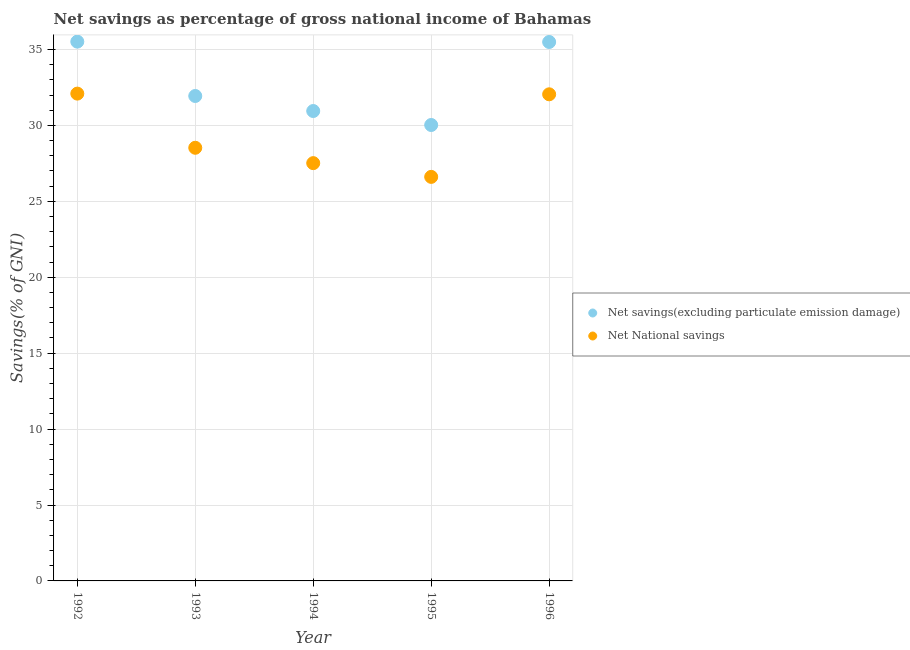How many different coloured dotlines are there?
Your response must be concise. 2. Is the number of dotlines equal to the number of legend labels?
Provide a succinct answer. Yes. What is the net national savings in 1996?
Offer a terse response. 32.05. Across all years, what is the maximum net national savings?
Offer a very short reply. 32.09. Across all years, what is the minimum net savings(excluding particulate emission damage)?
Your response must be concise. 30.03. What is the total net savings(excluding particulate emission damage) in the graph?
Ensure brevity in your answer.  163.92. What is the difference between the net savings(excluding particulate emission damage) in 1992 and that in 1996?
Provide a short and direct response. 0.02. What is the difference between the net savings(excluding particulate emission damage) in 1993 and the net national savings in 1995?
Offer a terse response. 5.33. What is the average net savings(excluding particulate emission damage) per year?
Provide a short and direct response. 32.78. In the year 1995, what is the difference between the net savings(excluding particulate emission damage) and net national savings?
Keep it short and to the point. 3.42. In how many years, is the net savings(excluding particulate emission damage) greater than 30 %?
Give a very brief answer. 5. What is the ratio of the net savings(excluding particulate emission damage) in 1994 to that in 1996?
Provide a succinct answer. 0.87. Is the net national savings in 1992 less than that in 1994?
Give a very brief answer. No. Is the difference between the net savings(excluding particulate emission damage) in 1994 and 1995 greater than the difference between the net national savings in 1994 and 1995?
Provide a succinct answer. Yes. What is the difference between the highest and the second highest net savings(excluding particulate emission damage)?
Provide a succinct answer. 0.02. What is the difference between the highest and the lowest net national savings?
Give a very brief answer. 5.48. How many dotlines are there?
Offer a terse response. 2. Where does the legend appear in the graph?
Offer a terse response. Center right. What is the title of the graph?
Offer a very short reply. Net savings as percentage of gross national income of Bahamas. Does "Electricity" appear as one of the legend labels in the graph?
Provide a succinct answer. No. What is the label or title of the X-axis?
Your answer should be compact. Year. What is the label or title of the Y-axis?
Make the answer very short. Savings(% of GNI). What is the Savings(% of GNI) of Net savings(excluding particulate emission damage) in 1992?
Offer a terse response. 35.52. What is the Savings(% of GNI) of Net National savings in 1992?
Ensure brevity in your answer.  32.09. What is the Savings(% of GNI) of Net savings(excluding particulate emission damage) in 1993?
Make the answer very short. 31.94. What is the Savings(% of GNI) in Net National savings in 1993?
Provide a succinct answer. 28.53. What is the Savings(% of GNI) in Net savings(excluding particulate emission damage) in 1994?
Make the answer very short. 30.95. What is the Savings(% of GNI) in Net National savings in 1994?
Provide a short and direct response. 27.52. What is the Savings(% of GNI) of Net savings(excluding particulate emission damage) in 1995?
Provide a short and direct response. 30.03. What is the Savings(% of GNI) in Net National savings in 1995?
Your answer should be very brief. 26.61. What is the Savings(% of GNI) in Net savings(excluding particulate emission damage) in 1996?
Ensure brevity in your answer.  35.49. What is the Savings(% of GNI) in Net National savings in 1996?
Offer a terse response. 32.05. Across all years, what is the maximum Savings(% of GNI) in Net savings(excluding particulate emission damage)?
Your answer should be very brief. 35.52. Across all years, what is the maximum Savings(% of GNI) in Net National savings?
Offer a terse response. 32.09. Across all years, what is the minimum Savings(% of GNI) in Net savings(excluding particulate emission damage)?
Make the answer very short. 30.03. Across all years, what is the minimum Savings(% of GNI) in Net National savings?
Provide a short and direct response. 26.61. What is the total Savings(% of GNI) of Net savings(excluding particulate emission damage) in the graph?
Offer a very short reply. 163.92. What is the total Savings(% of GNI) of Net National savings in the graph?
Offer a very short reply. 146.79. What is the difference between the Savings(% of GNI) of Net savings(excluding particulate emission damage) in 1992 and that in 1993?
Your answer should be very brief. 3.58. What is the difference between the Savings(% of GNI) in Net National savings in 1992 and that in 1993?
Offer a terse response. 3.57. What is the difference between the Savings(% of GNI) in Net savings(excluding particulate emission damage) in 1992 and that in 1994?
Keep it short and to the point. 4.57. What is the difference between the Savings(% of GNI) in Net National savings in 1992 and that in 1994?
Ensure brevity in your answer.  4.58. What is the difference between the Savings(% of GNI) in Net savings(excluding particulate emission damage) in 1992 and that in 1995?
Give a very brief answer. 5.49. What is the difference between the Savings(% of GNI) of Net National savings in 1992 and that in 1995?
Make the answer very short. 5.48. What is the difference between the Savings(% of GNI) in Net savings(excluding particulate emission damage) in 1992 and that in 1996?
Keep it short and to the point. 0.02. What is the difference between the Savings(% of GNI) of Net National savings in 1992 and that in 1996?
Your answer should be compact. 0.05. What is the difference between the Savings(% of GNI) in Net National savings in 1993 and that in 1994?
Offer a very short reply. 1.01. What is the difference between the Savings(% of GNI) of Net savings(excluding particulate emission damage) in 1993 and that in 1995?
Your answer should be very brief. 1.91. What is the difference between the Savings(% of GNI) in Net National savings in 1993 and that in 1995?
Offer a very short reply. 1.92. What is the difference between the Savings(% of GNI) of Net savings(excluding particulate emission damage) in 1993 and that in 1996?
Your answer should be very brief. -3.56. What is the difference between the Savings(% of GNI) in Net National savings in 1993 and that in 1996?
Provide a succinct answer. -3.52. What is the difference between the Savings(% of GNI) of Net savings(excluding particulate emission damage) in 1994 and that in 1995?
Keep it short and to the point. 0.92. What is the difference between the Savings(% of GNI) in Net National savings in 1994 and that in 1995?
Keep it short and to the point. 0.9. What is the difference between the Savings(% of GNI) of Net savings(excluding particulate emission damage) in 1994 and that in 1996?
Your answer should be compact. -4.55. What is the difference between the Savings(% of GNI) of Net National savings in 1994 and that in 1996?
Your answer should be compact. -4.53. What is the difference between the Savings(% of GNI) of Net savings(excluding particulate emission damage) in 1995 and that in 1996?
Keep it short and to the point. -5.47. What is the difference between the Savings(% of GNI) of Net National savings in 1995 and that in 1996?
Provide a short and direct response. -5.44. What is the difference between the Savings(% of GNI) of Net savings(excluding particulate emission damage) in 1992 and the Savings(% of GNI) of Net National savings in 1993?
Provide a succinct answer. 6.99. What is the difference between the Savings(% of GNI) in Net savings(excluding particulate emission damage) in 1992 and the Savings(% of GNI) in Net National savings in 1994?
Ensure brevity in your answer.  8. What is the difference between the Savings(% of GNI) in Net savings(excluding particulate emission damage) in 1992 and the Savings(% of GNI) in Net National savings in 1995?
Your response must be concise. 8.91. What is the difference between the Savings(% of GNI) in Net savings(excluding particulate emission damage) in 1992 and the Savings(% of GNI) in Net National savings in 1996?
Provide a short and direct response. 3.47. What is the difference between the Savings(% of GNI) in Net savings(excluding particulate emission damage) in 1993 and the Savings(% of GNI) in Net National savings in 1994?
Keep it short and to the point. 4.42. What is the difference between the Savings(% of GNI) in Net savings(excluding particulate emission damage) in 1993 and the Savings(% of GNI) in Net National savings in 1995?
Your response must be concise. 5.33. What is the difference between the Savings(% of GNI) of Net savings(excluding particulate emission damage) in 1993 and the Savings(% of GNI) of Net National savings in 1996?
Keep it short and to the point. -0.11. What is the difference between the Savings(% of GNI) of Net savings(excluding particulate emission damage) in 1994 and the Savings(% of GNI) of Net National savings in 1995?
Offer a very short reply. 4.34. What is the difference between the Savings(% of GNI) in Net savings(excluding particulate emission damage) in 1994 and the Savings(% of GNI) in Net National savings in 1996?
Give a very brief answer. -1.1. What is the difference between the Savings(% of GNI) of Net savings(excluding particulate emission damage) in 1995 and the Savings(% of GNI) of Net National savings in 1996?
Provide a short and direct response. -2.02. What is the average Savings(% of GNI) in Net savings(excluding particulate emission damage) per year?
Offer a terse response. 32.78. What is the average Savings(% of GNI) of Net National savings per year?
Offer a very short reply. 29.36. In the year 1992, what is the difference between the Savings(% of GNI) of Net savings(excluding particulate emission damage) and Savings(% of GNI) of Net National savings?
Provide a short and direct response. 3.42. In the year 1993, what is the difference between the Savings(% of GNI) of Net savings(excluding particulate emission damage) and Savings(% of GNI) of Net National savings?
Your response must be concise. 3.41. In the year 1994, what is the difference between the Savings(% of GNI) of Net savings(excluding particulate emission damage) and Savings(% of GNI) of Net National savings?
Ensure brevity in your answer.  3.43. In the year 1995, what is the difference between the Savings(% of GNI) in Net savings(excluding particulate emission damage) and Savings(% of GNI) in Net National savings?
Your answer should be very brief. 3.42. In the year 1996, what is the difference between the Savings(% of GNI) in Net savings(excluding particulate emission damage) and Savings(% of GNI) in Net National savings?
Provide a succinct answer. 3.45. What is the ratio of the Savings(% of GNI) of Net savings(excluding particulate emission damage) in 1992 to that in 1993?
Provide a short and direct response. 1.11. What is the ratio of the Savings(% of GNI) of Net National savings in 1992 to that in 1993?
Offer a very short reply. 1.13. What is the ratio of the Savings(% of GNI) in Net savings(excluding particulate emission damage) in 1992 to that in 1994?
Offer a very short reply. 1.15. What is the ratio of the Savings(% of GNI) in Net National savings in 1992 to that in 1994?
Your answer should be compact. 1.17. What is the ratio of the Savings(% of GNI) in Net savings(excluding particulate emission damage) in 1992 to that in 1995?
Your response must be concise. 1.18. What is the ratio of the Savings(% of GNI) in Net National savings in 1992 to that in 1995?
Give a very brief answer. 1.21. What is the ratio of the Savings(% of GNI) of Net savings(excluding particulate emission damage) in 1992 to that in 1996?
Provide a short and direct response. 1. What is the ratio of the Savings(% of GNI) of Net savings(excluding particulate emission damage) in 1993 to that in 1994?
Give a very brief answer. 1.03. What is the ratio of the Savings(% of GNI) of Net National savings in 1993 to that in 1994?
Your answer should be very brief. 1.04. What is the ratio of the Savings(% of GNI) of Net savings(excluding particulate emission damage) in 1993 to that in 1995?
Ensure brevity in your answer.  1.06. What is the ratio of the Savings(% of GNI) in Net National savings in 1993 to that in 1995?
Your answer should be compact. 1.07. What is the ratio of the Savings(% of GNI) in Net savings(excluding particulate emission damage) in 1993 to that in 1996?
Provide a succinct answer. 0.9. What is the ratio of the Savings(% of GNI) in Net National savings in 1993 to that in 1996?
Keep it short and to the point. 0.89. What is the ratio of the Savings(% of GNI) of Net savings(excluding particulate emission damage) in 1994 to that in 1995?
Ensure brevity in your answer.  1.03. What is the ratio of the Savings(% of GNI) in Net National savings in 1994 to that in 1995?
Make the answer very short. 1.03. What is the ratio of the Savings(% of GNI) of Net savings(excluding particulate emission damage) in 1994 to that in 1996?
Offer a terse response. 0.87. What is the ratio of the Savings(% of GNI) of Net National savings in 1994 to that in 1996?
Keep it short and to the point. 0.86. What is the ratio of the Savings(% of GNI) of Net savings(excluding particulate emission damage) in 1995 to that in 1996?
Your response must be concise. 0.85. What is the ratio of the Savings(% of GNI) in Net National savings in 1995 to that in 1996?
Provide a short and direct response. 0.83. What is the difference between the highest and the second highest Savings(% of GNI) in Net savings(excluding particulate emission damage)?
Ensure brevity in your answer.  0.02. What is the difference between the highest and the second highest Savings(% of GNI) in Net National savings?
Make the answer very short. 0.05. What is the difference between the highest and the lowest Savings(% of GNI) of Net savings(excluding particulate emission damage)?
Ensure brevity in your answer.  5.49. What is the difference between the highest and the lowest Savings(% of GNI) of Net National savings?
Ensure brevity in your answer.  5.48. 